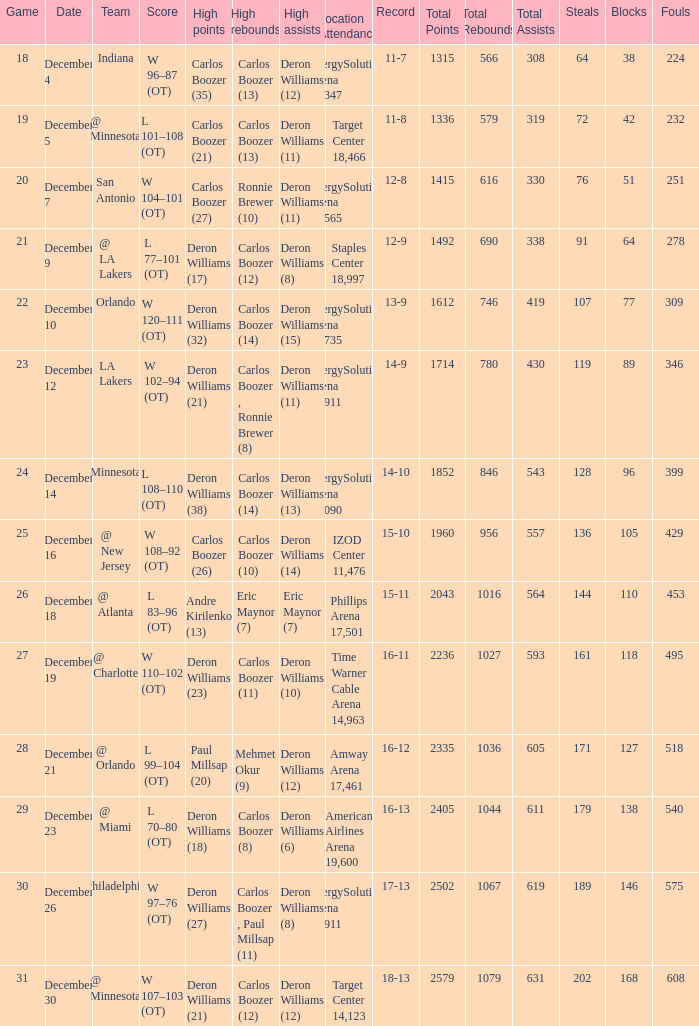Would you be able to parse every entry in this table? {'header': ['Game', 'Date', 'Team', 'Score', 'High points', 'High rebounds', 'High assists', 'Location Attendance', 'Record', 'Total Points', 'Total Rebounds', 'Total Assists', 'Steals', 'Blocks', 'Fouls'], 'rows': [['18', 'December 4', 'Indiana', 'W 96–87 (OT)', 'Carlos Boozer (35)', 'Carlos Boozer (13)', 'Deron Williams (12)', 'EnergySolutions Arena 19,347', '11-7', '1315', '566', '308', '64', '38', '224'], ['19', 'December 5', '@ Minnesota', 'L 101–108 (OT)', 'Carlos Boozer (21)', 'Carlos Boozer (13)', 'Deron Williams (11)', 'Target Center 18,466', '11-8', '1336', '579', '319', '72', '42', '232'], ['20', 'December 7', 'San Antonio', 'W 104–101 (OT)', 'Carlos Boozer (27)', 'Ronnie Brewer (10)', 'Deron Williams (11)', 'EnergySolutions Arena 17,565', '12-8', '1415', '616', '330', '76', '51', '251'], ['21', 'December 9', '@ LA Lakers', 'L 77–101 (OT)', 'Deron Williams (17)', 'Carlos Boozer (12)', 'Deron Williams (8)', 'Staples Center 18,997', '12-9', '1492', '690', '338', '91', '64', '278'], ['22', 'December 10', 'Orlando', 'W 120–111 (OT)', 'Deron Williams (32)', 'Carlos Boozer (14)', 'Deron Williams (15)', 'EnergySolutions Arena 18,735', '13-9', '1612', '746', '419', '107', '77', '309 '], ['23', 'December 12', 'LA Lakers', 'W 102–94 (OT)', 'Deron Williams (21)', 'Carlos Boozer , Ronnie Brewer (8)', 'Deron Williams (11)', 'EnergySolutions Arena 19,911', '14-9', '1714', '780', '430', '119', '89', '346 '], ['24', 'December 14', 'Minnesota', 'L 108–110 (OT)', 'Deron Williams (38)', 'Carlos Boozer (14)', 'Deron Williams (13)', 'EnergySolutions Arena 18,090', '14-10', '1852', '846', '543', '128', '96', '399 '], ['25', 'December 16', '@ New Jersey', 'W 108–92 (OT)', 'Carlos Boozer (26)', 'Carlos Boozer (10)', 'Deron Williams (14)', 'IZOD Center 11,476', '15-10', '1960', '956', '557', '136', '105', '429 '], ['26', 'December 18', '@ Atlanta', 'L 83–96 (OT)', 'Andre Kirilenko (13)', 'Eric Maynor (7)', 'Eric Maynor (7)', 'Phillips Arena 17,501', '15-11', '2043', '1016', '564', '144', '110', '453'], ['27', 'December 19', '@ Charlotte', 'W 110–102 (OT)', 'Deron Williams (23)', 'Carlos Boozer (11)', 'Deron Williams (10)', 'Time Warner Cable Arena 14,963', '16-11', '2236', '1027', '593', '161', '118', '495 '], ['28', 'December 21', '@ Orlando', 'L 99–104 (OT)', 'Paul Millsap (20)', 'Mehmet Okur (9)', 'Deron Williams (12)', 'Amway Arena 17,461', '16-12', '2335', '1036', '605', '171', '127', '518 '], ['29', 'December 23', '@ Miami', 'L 70–80 (OT)', 'Deron Williams (18)', 'Carlos Boozer (8)', 'Deron Williams (6)', 'American Airlines Arena 19,600', '16-13', '2405', '1044', '611', '179', '138', '540 '], ['30', 'December 26', 'Philadelphia', 'W 97–76 (OT)', 'Deron Williams (27)', 'Carlos Boozer , Paul Millsap (11)', 'Deron Williams (8)', 'EnergySolutions Arena 19,911', '17-13', '2502', '1067', '619', '189', '146', '575 '], ['31', 'December 30', '@ Minnesota', 'W 107–103 (OT)', 'Deron Williams (21)', 'Carlos Boozer (12)', 'Deron Williams (12)', 'Target Center 14,123', '18-13', '2579', '1079', '631', '202', '168', '608']]} When was the game in which Deron Williams (13) did the high assists played? December 14. 